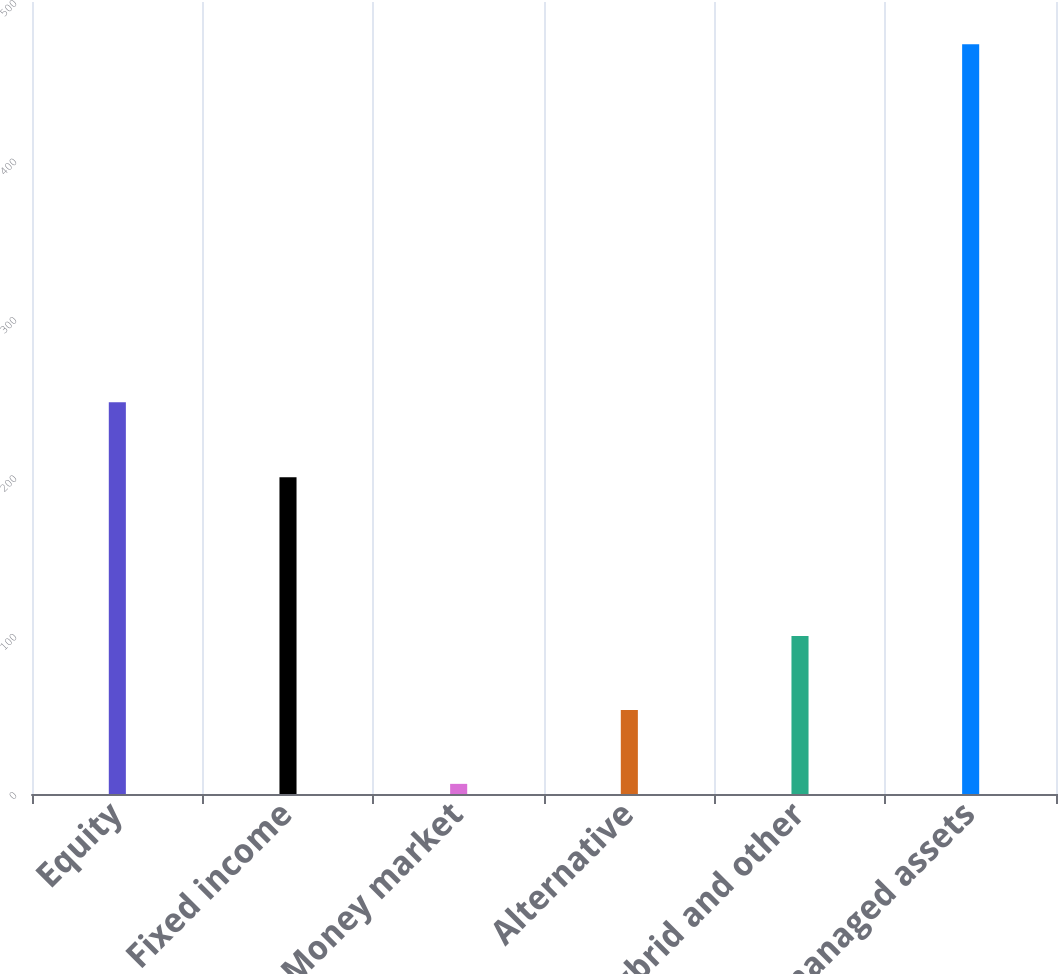Convert chart to OTSL. <chart><loc_0><loc_0><loc_500><loc_500><bar_chart><fcel>Equity<fcel>Fixed income<fcel>Money market<fcel>Alternative<fcel>Hybrid and other<fcel>Total managed assets<nl><fcel>247.3<fcel>199.9<fcel>6.4<fcel>53.09<fcel>99.78<fcel>473.3<nl></chart> 